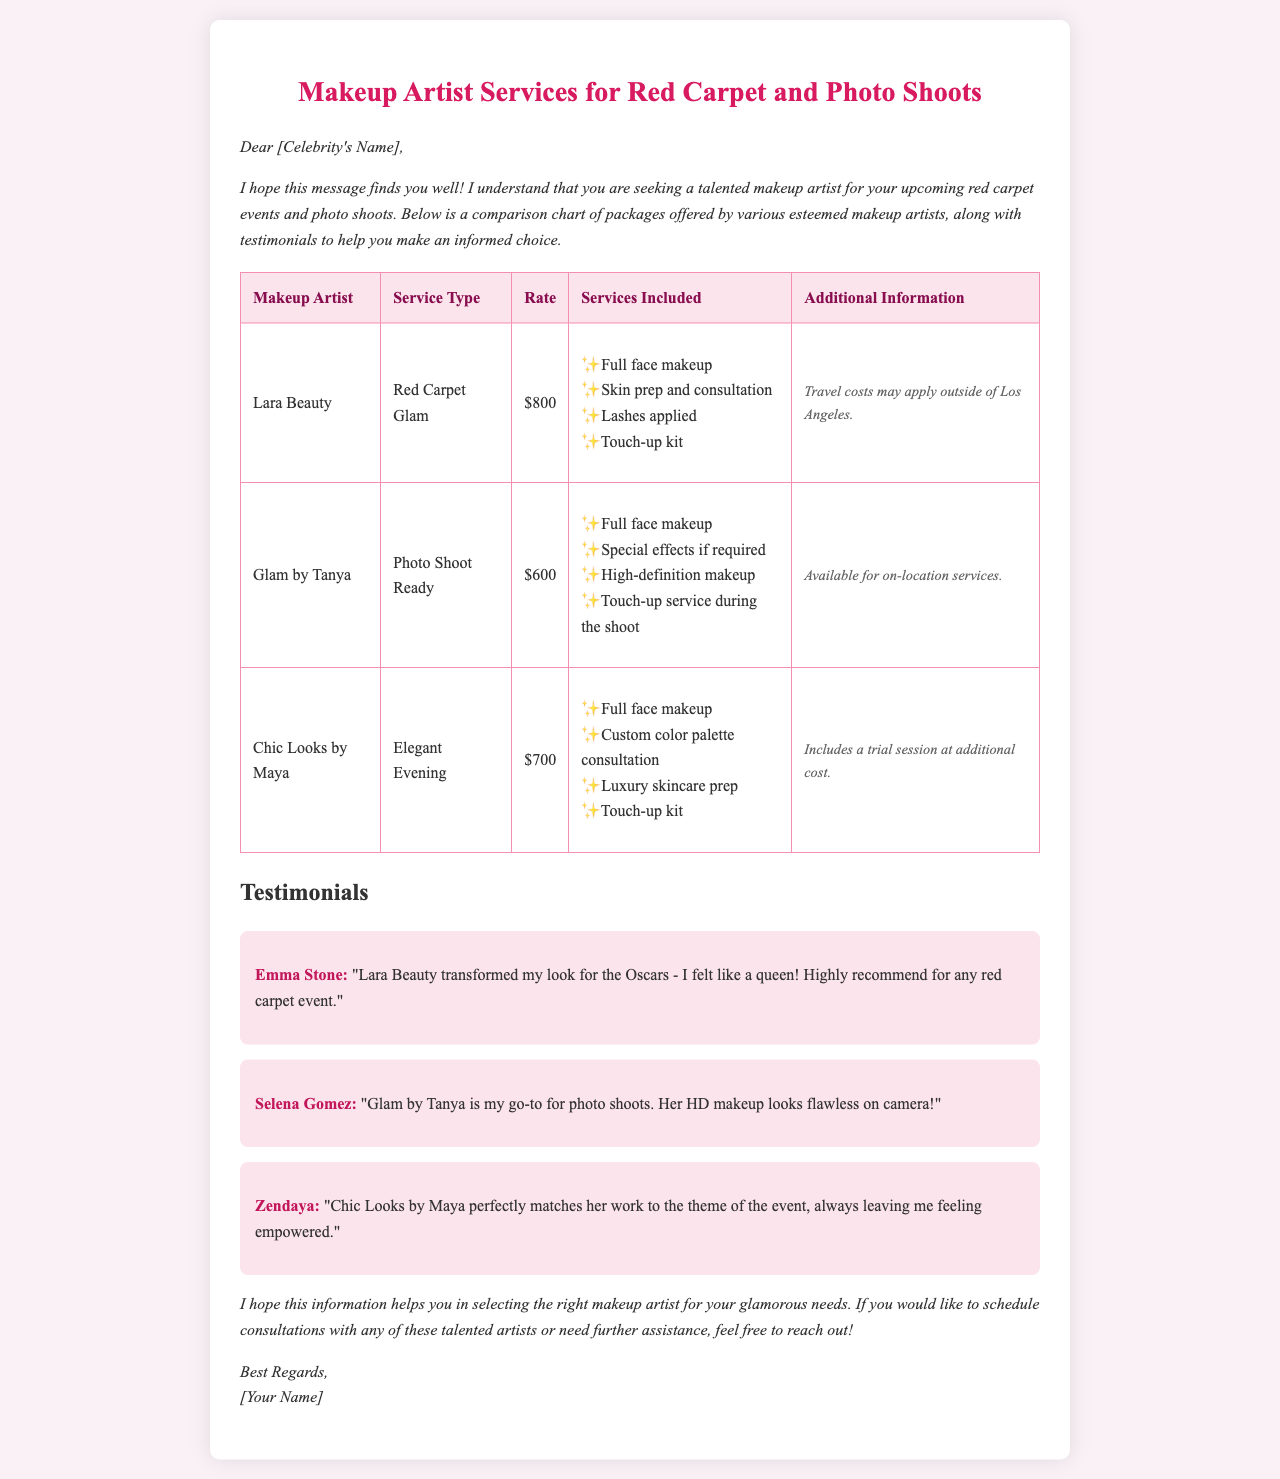What is the rate for Lara Beauty's services? Lara Beauty's rate for the Red Carpet Glam service is listed in the document as $800.
Answer: $800 What services are included with Glam by Tanya? The services included with Glam by Tanya for the Photo Shoot Ready package are listed in bullet points and include full face makeup and touch-up service during the shoot.
Answer: Full face makeup, Special effects if required, High-definition makeup, Touch-up service during the shoot Who provided a testimonial for Chic Looks by Maya? The testimonial for Chic Looks by Maya was provided by Zendaya, as mentioned in the document.
Answer: Zendaya Which makeup artist has an additional cost for a trial session? The document states that Chic Looks by Maya includes a trial session at additional cost, indicating that this artist has that provision.
Answer: Chic Looks by Maya What is the additional information for Lara Beauty's services? The additional information for Lara Beauty specifies that travel costs may apply outside of Los Angeles, which is important for potential clients to know.
Answer: Travel costs may apply outside of Los Angeles Which service is offered at the lowest rate? By comparing the rates listed in the document, Glam by Tanya offers the lowest rate for the Photo Shoot Ready service at $600.
Answer: $600 What is the overall purpose of the document? The overall purpose of the document is to help the celebrity find a suitable makeup artist for red carpet events and photo shoots by providing comparisons of rates, services, and client testimonials.
Answer: To help find a suitable makeup artist What type of event does Lara Beauty focus on? Based on the document, Lara Beauty focuses on Red Carpet events by providing a specific package for Red Carpet Glam.
Answer: Red Carpet 